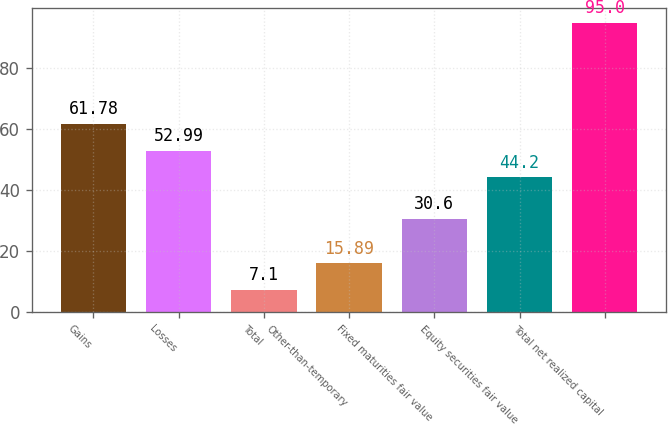Convert chart to OTSL. <chart><loc_0><loc_0><loc_500><loc_500><bar_chart><fcel>Gains<fcel>Losses<fcel>Total<fcel>Other-than-temporary<fcel>Fixed maturities fair value<fcel>Equity securities fair value<fcel>Total net realized capital<nl><fcel>61.78<fcel>52.99<fcel>7.1<fcel>15.89<fcel>30.6<fcel>44.2<fcel>95<nl></chart> 